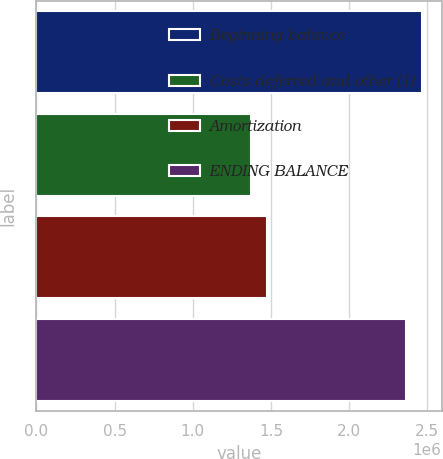Convert chart to OTSL. <chart><loc_0><loc_0><loc_500><loc_500><bar_chart><fcel>Beginning balance<fcel>Costs deferred and other (1)<fcel>Amortization<fcel>ENDING BALANCE<nl><fcel>2.46722e+06<fcel>1.3724e+06<fcel>1.47345e+06<fcel>2.36618e+06<nl></chart> 